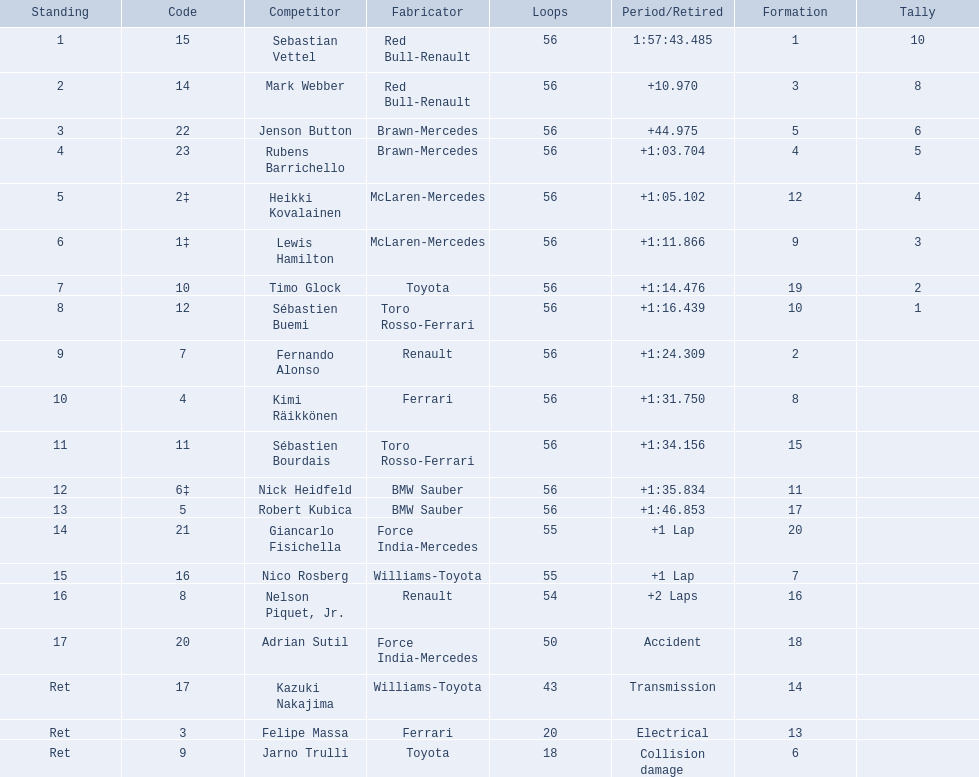Who were all of the drivers in the 2009 chinese grand prix? Sebastian Vettel, Mark Webber, Jenson Button, Rubens Barrichello, Heikki Kovalainen, Lewis Hamilton, Timo Glock, Sébastien Buemi, Fernando Alonso, Kimi Räikkönen, Sébastien Bourdais, Nick Heidfeld, Robert Kubica, Giancarlo Fisichella, Nico Rosberg, Nelson Piquet, Jr., Adrian Sutil, Kazuki Nakajima, Felipe Massa, Jarno Trulli. And what were their finishing times? 1:57:43.485, +10.970, +44.975, +1:03.704, +1:05.102, +1:11.866, +1:14.476, +1:16.439, +1:24.309, +1:31.750, +1:34.156, +1:35.834, +1:46.853, +1 Lap, +1 Lap, +2 Laps, Accident, Transmission, Electrical, Collision damage. Which player faced collision damage and retired from the race? Jarno Trulli. 